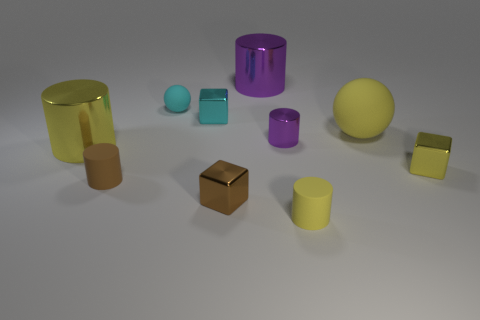What number of tiny metallic cubes have the same color as the tiny ball?
Provide a short and direct response. 1. Is the shape of the small object right of the tiny yellow rubber object the same as  the cyan shiny object?
Provide a short and direct response. Yes. There is a yellow thing that is right of the yellow matte object that is behind the purple shiny cylinder that is in front of the large purple metal object; what is its shape?
Provide a succinct answer. Cube. What is the size of the yellow ball?
Keep it short and to the point. Large. What color is the other cylinder that is made of the same material as the brown cylinder?
Your response must be concise. Yellow. How many other purple cylinders are the same material as the tiny purple cylinder?
Offer a very short reply. 1. There is a tiny rubber ball; does it have the same color as the block that is right of the small purple object?
Your answer should be compact. No. What color is the small shiny block that is behind the big shiny cylinder in front of the cyan ball?
Your answer should be compact. Cyan. There is a ball that is the same size as the yellow cube; what color is it?
Give a very brief answer. Cyan. Is there another yellow rubber thing that has the same shape as the tiny yellow matte thing?
Your answer should be compact. No. 